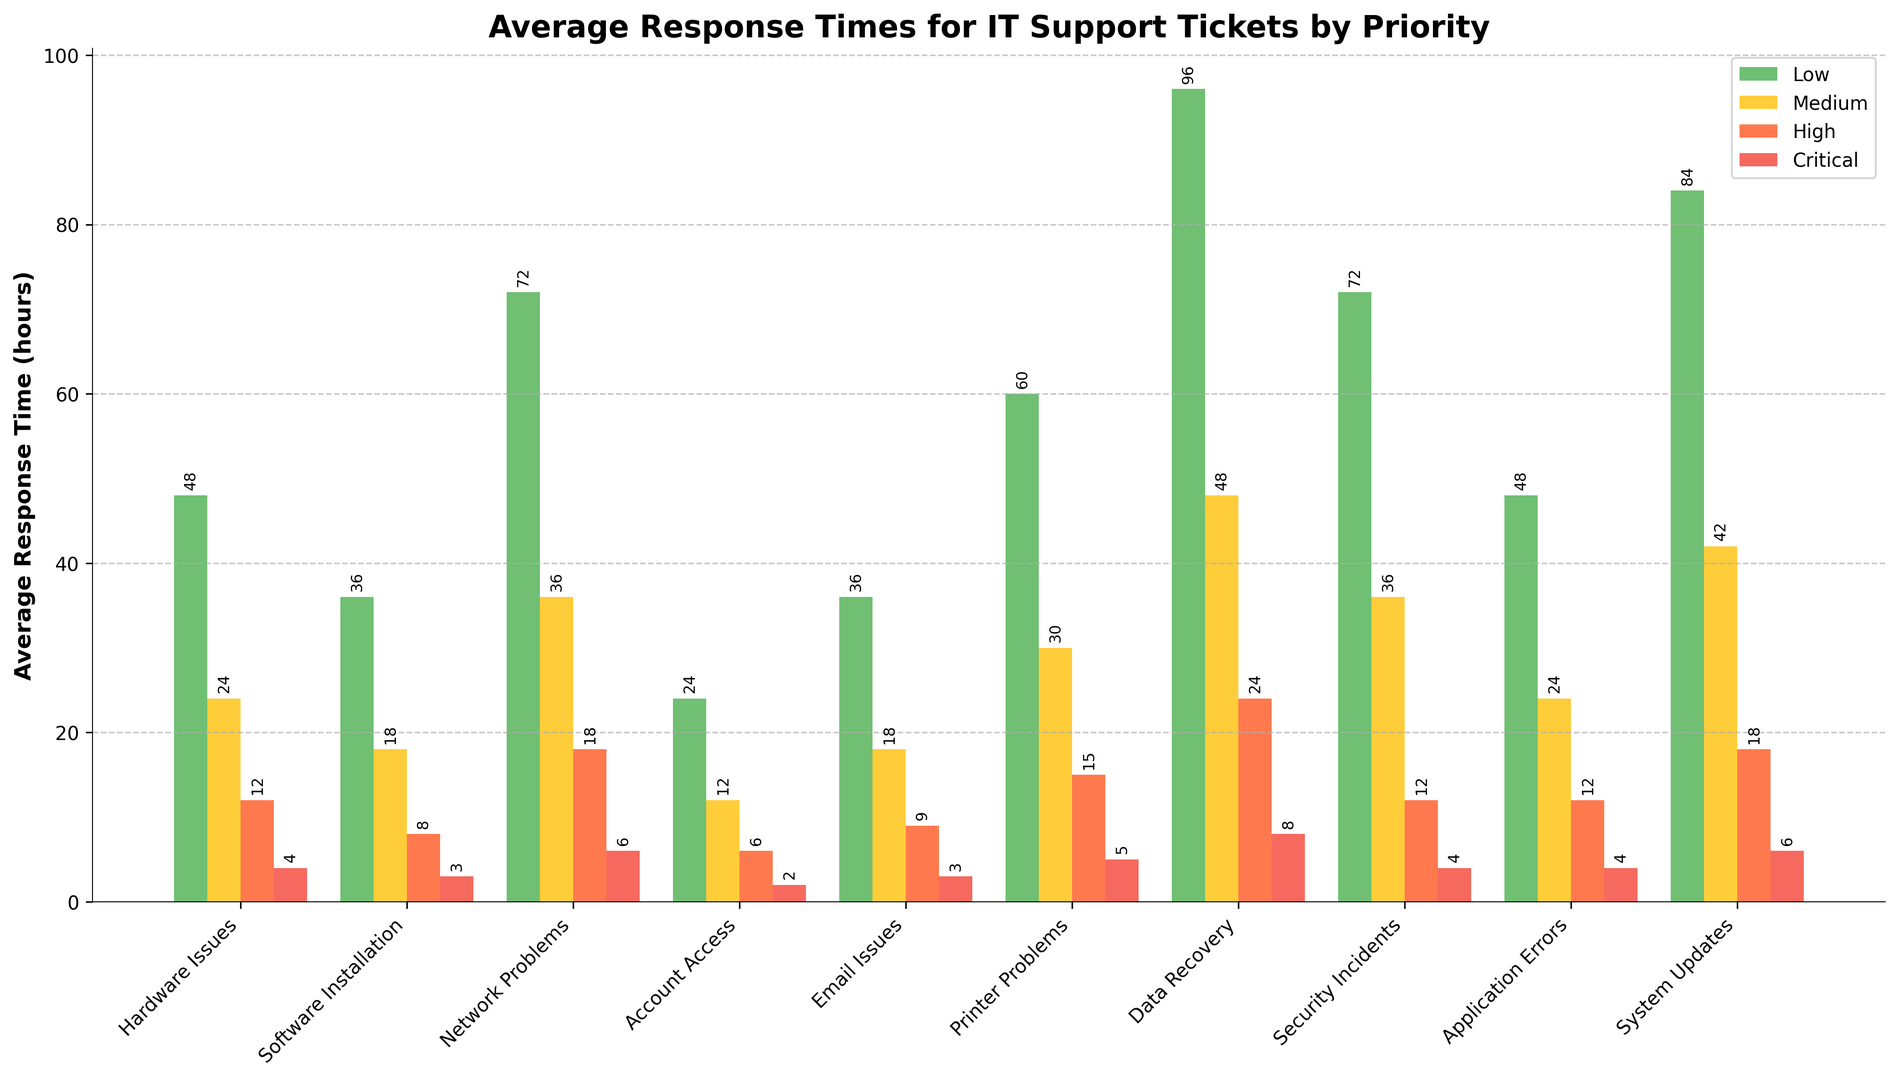Which category has the shortest average response time for critical priority tickets? The bar for critical priority tickets is red, and by observing all red bars for each category, "Account Access" has the smallest one.
Answer: Account Access What is the difference in the average response time between low and high priority network problems? The bar heights show low priority network problems at 72 hours and high priority network problems at 18 hours. The difference is 72 - 18 = 54 hours.
Answer: 54 hours Which category has the highest average response time for medium priority tickets? By looking at the yellow bars representing medium priority tickets, "Data Recovery" has the highest bar.
Answer: Data Recovery How does the average response time for high priority security incidents compare to high priority hardware issues? The red bar for high priority security incidents is at 12 hours, the same as high priority hardware issues.
Answer: Equal What is the total average response time for all priorities in the category "System Updates"? Add the heights of all bars for "System Updates": 84 (Low) + 42 (Medium) + 18 (High) + 6 (Critical) = 150 hours.
Answer: 150 hours For "Email Issues," how does the response time for critical priority tickets compare to medium priority? The red bar for critical priority email issues is at 3 hours, and the yellow bar for medium priority is at 18 hours. 3 is less than 18.
Answer: Less What is the average of the response times for high priority tickets across all categories? Sum all high priority bars: 12 (Hardware) + 8 (Software) + 18 (Network) + 6 (Account) + 9 (Email) + 15 (Printer) + 24 (Data) + 12 (Security) + 12 (Application) + 18 (System) = 134. Total categories = 10, so average is 134/10 = 13.4 hours.
Answer: 13.4 hours Which priority level generally has the shortest average response times across all categories? By visually comparing all color-coded bar heights (green for low, yellow for medium, red for high, dark red for critical), the dark red (critical priority) generally have the shortest bars.
Answer: Critical How much longer is the response time for low priority data recovery compared to medium priority data recovery? The bar for low priority data recovery is at 96 hours and the bar for medium priority is at 48 hours. The difference is 96 - 48 = 48 hours.
Answer: 48 hours 